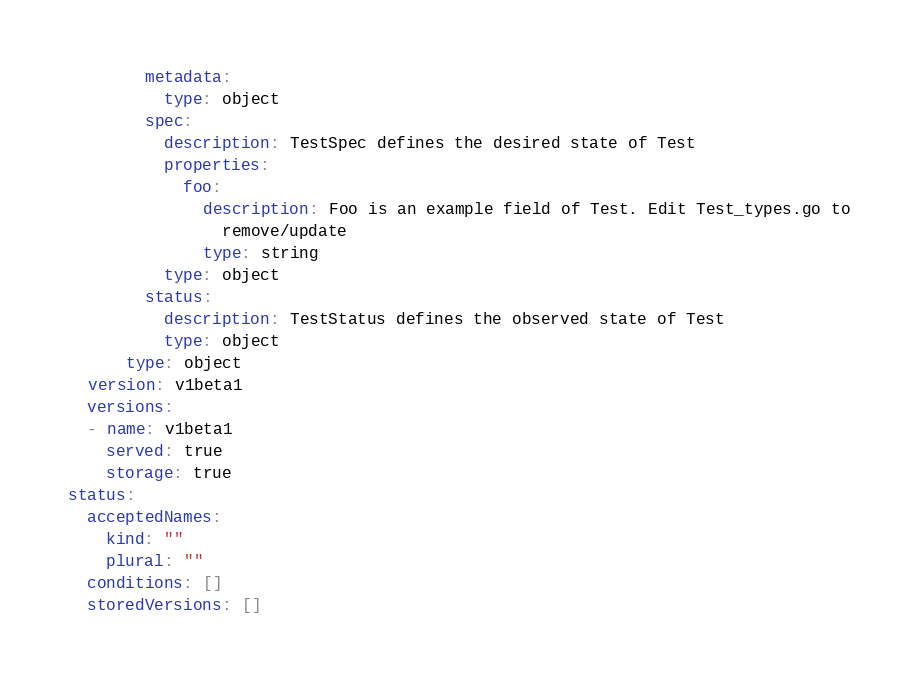Convert code to text. <code><loc_0><loc_0><loc_500><loc_500><_YAML_>        metadata:
          type: object
        spec:
          description: TestSpec defines the desired state of Test
          properties:
            foo:
              description: Foo is an example field of Test. Edit Test_types.go to
                remove/update
              type: string
          type: object
        status:
          description: TestStatus defines the observed state of Test
          type: object
      type: object
  version: v1beta1
  versions:
  - name: v1beta1
    served: true
    storage: true
status:
  acceptedNames:
    kind: ""
    plural: ""
  conditions: []
  storedVersions: []
</code> 